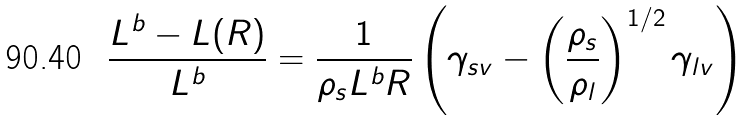Convert formula to latex. <formula><loc_0><loc_0><loc_500><loc_500>\frac { L ^ { b } - L ( R ) } { L ^ { b } } = \frac { 1 } { \rho _ { s } L ^ { b } R } \left ( \gamma _ { s v } - \left ( \frac { \rho _ { s } } { \rho _ { l } } \right ) ^ { 1 / 2 } \gamma _ { l v } \right )</formula> 